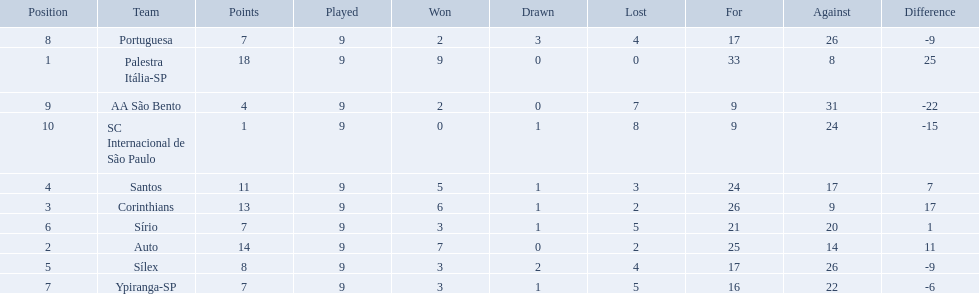What teams played in 1926? Palestra Itália-SP, Auto, Corinthians, Santos, Sílex, Sírio, Ypiranga-SP, Portuguesa, AA São Bento, SC Internacional de São Paulo. Did any team lose zero games? Palestra Itália-SP. 